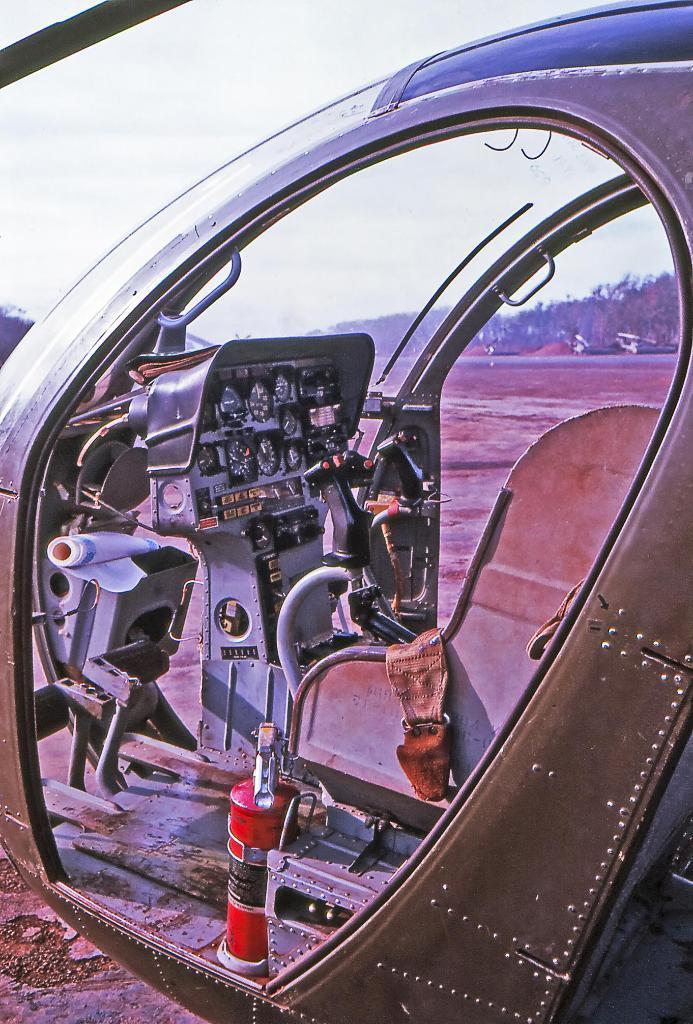In one or two sentences, can you explain what this image depicts? This is an edited picture, in this picture there is a helicopter. In the center it is soil. In the background there are trees and other objects. Sky is cloudy. 